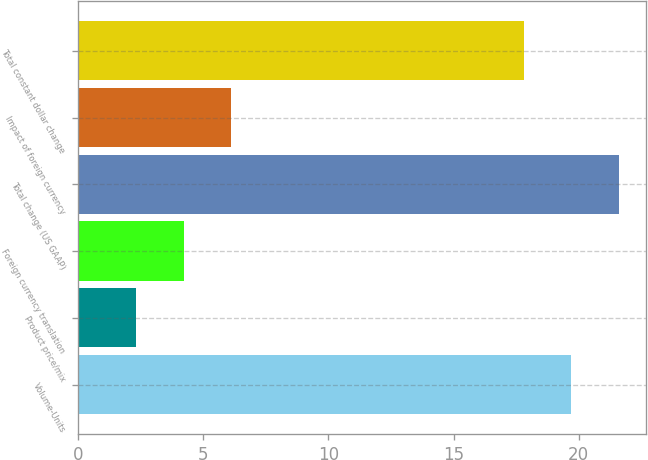Convert chart. <chart><loc_0><loc_0><loc_500><loc_500><bar_chart><fcel>Volume-Units<fcel>Product price/mix<fcel>Foreign currency translation<fcel>Total change (US GAAP)<fcel>Impact of foreign currency<fcel>Total constant dollar change<nl><fcel>19.71<fcel>2.3<fcel>4.21<fcel>21.62<fcel>6.12<fcel>17.8<nl></chart> 